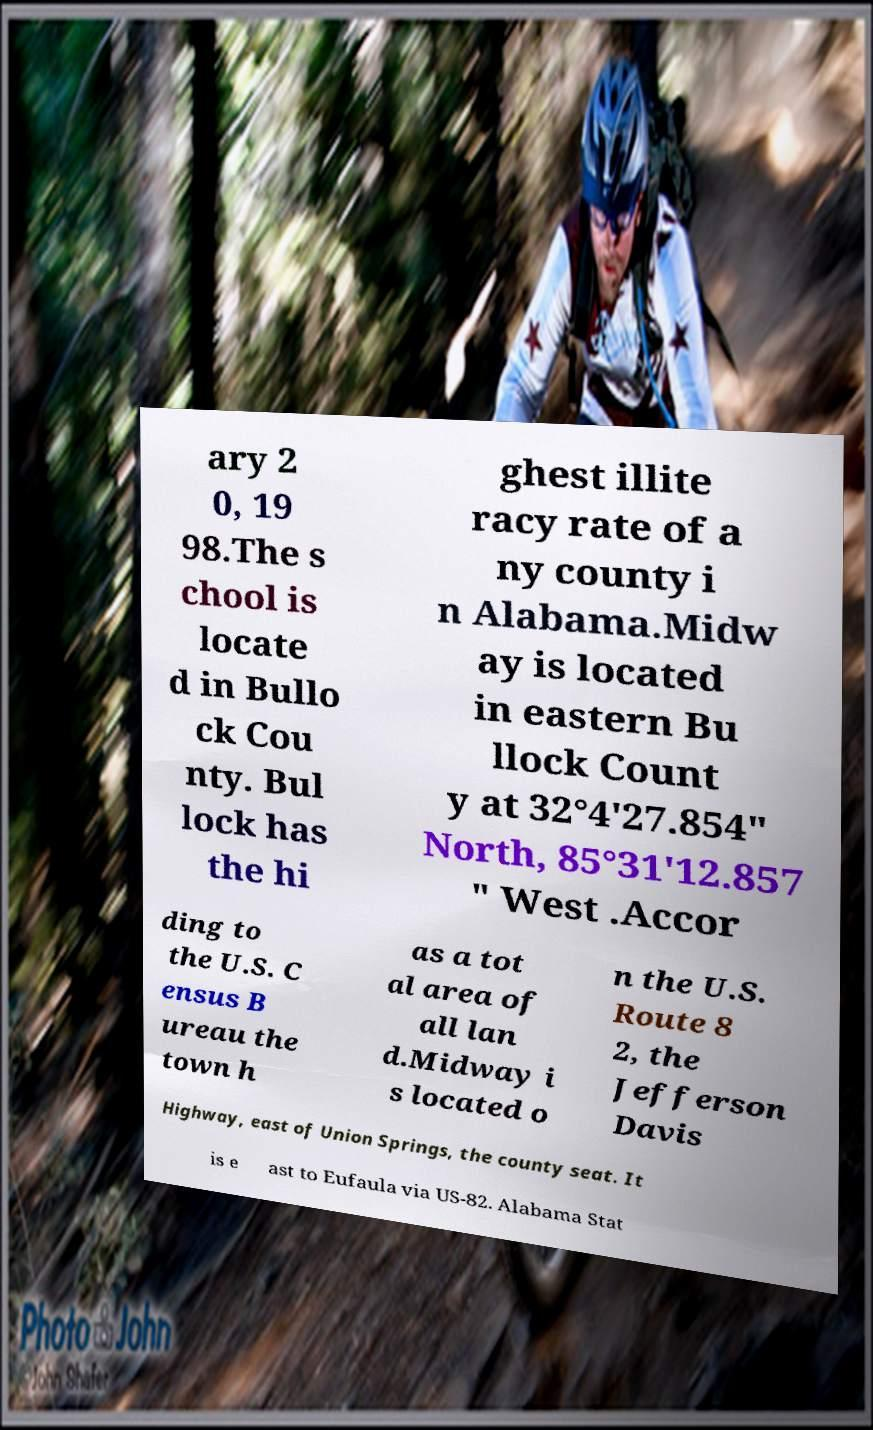For documentation purposes, I need the text within this image transcribed. Could you provide that? ary 2 0, 19 98.The s chool is locate d in Bullo ck Cou nty. Bul lock has the hi ghest illite racy rate of a ny county i n Alabama.Midw ay is located in eastern Bu llock Count y at 32°4'27.854" North, 85°31'12.857 " West .Accor ding to the U.S. C ensus B ureau the town h as a tot al area of all lan d.Midway i s located o n the U.S. Route 8 2, the Jefferson Davis Highway, east of Union Springs, the county seat. It is e ast to Eufaula via US-82. Alabama Stat 